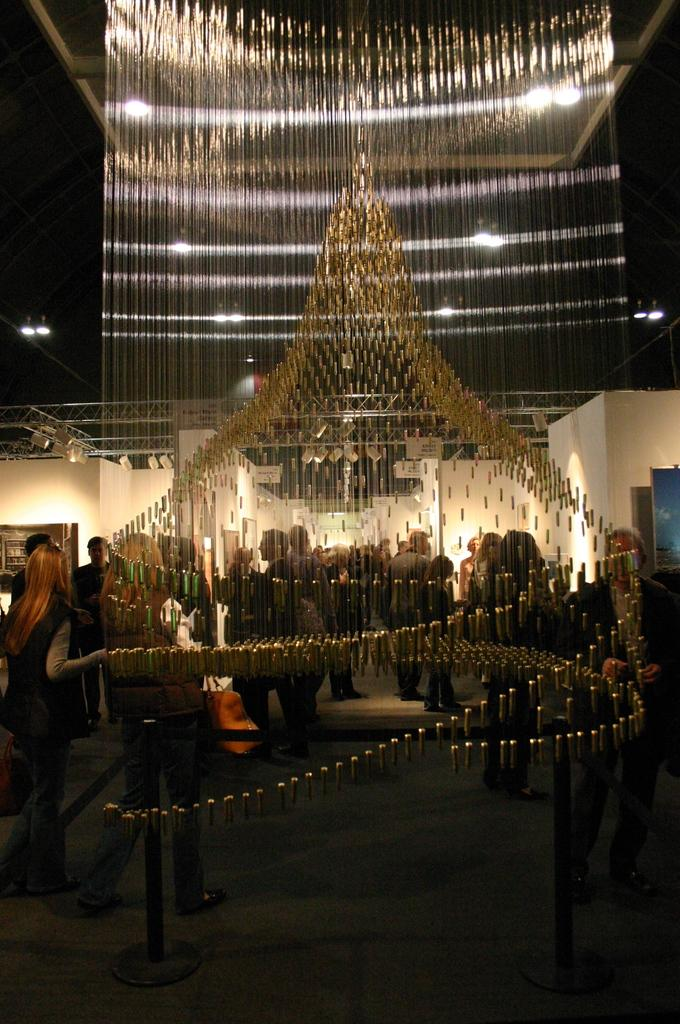What is the most prominent feature in the room? There is a big chandelier in the room. Are there any people present in the room? Yes, there are people standing in the room. What can be seen on the walls of the room? There are paintings on the wall. What type of science experiment is being conducted in the room? There is no indication of a science experiment being conducted in the room; the facts provided only mention a chandelier, people, and paintings on the wall. 